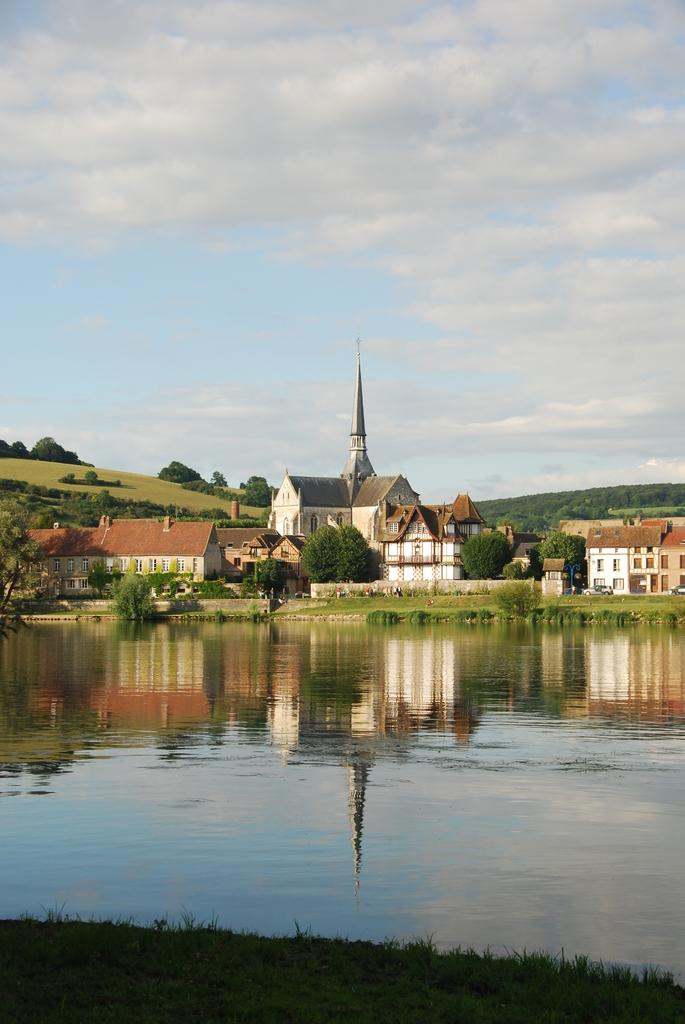What is the primary element visible in the image? There is water in the image. What type of structures can be seen in the image? There are buildings in the image. What type of vegetation is present in the image? There are trees in the image. What type of geographical feature is visible in the image? There are hills in the image. What is visible in the background of the image? The sky is visible in the background of the image. What type of committee can be seen meeting near the water in the image? There is no committee present in the image; it only features water, buildings, trees, hills, and the sky. 